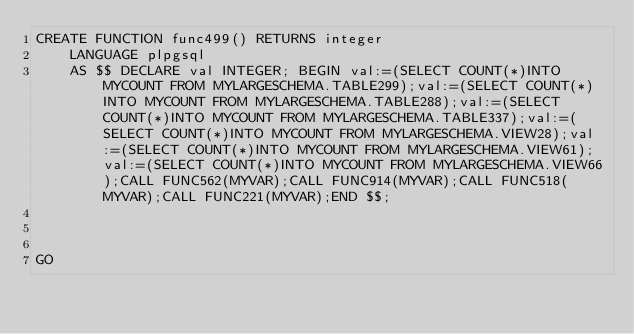Convert code to text. <code><loc_0><loc_0><loc_500><loc_500><_SQL_>CREATE FUNCTION func499() RETURNS integer
    LANGUAGE plpgsql
    AS $$ DECLARE val INTEGER; BEGIN val:=(SELECT COUNT(*)INTO MYCOUNT FROM MYLARGESCHEMA.TABLE299);val:=(SELECT COUNT(*)INTO MYCOUNT FROM MYLARGESCHEMA.TABLE288);val:=(SELECT COUNT(*)INTO MYCOUNT FROM MYLARGESCHEMA.TABLE337);val:=(SELECT COUNT(*)INTO MYCOUNT FROM MYLARGESCHEMA.VIEW28);val:=(SELECT COUNT(*)INTO MYCOUNT FROM MYLARGESCHEMA.VIEW61);val:=(SELECT COUNT(*)INTO MYCOUNT FROM MYLARGESCHEMA.VIEW66);CALL FUNC562(MYVAR);CALL FUNC914(MYVAR);CALL FUNC518(MYVAR);CALL FUNC221(MYVAR);END $$;



GO</code> 